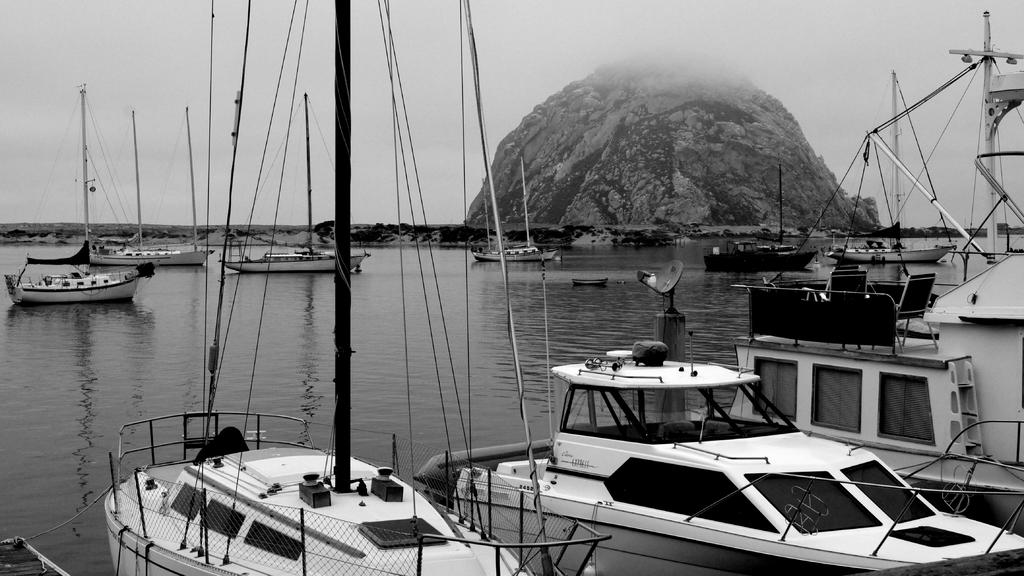What is the primary element in the image? There is water in the image. What can be seen floating on the water? There are boats in the image. What type of landform is visible in the image? There is a hill in the image. What is visible in the background of the image? The sky is visible in the background of the image. What type of rice is being harvested on the hill in the image? There is no rice or harvesting activity present in the image. What is the purpose of the boats in the image? The purpose of the boats in the image cannot be determined without additional context. 